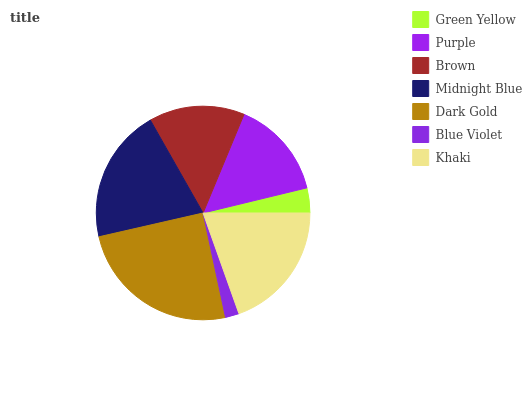Is Blue Violet the minimum?
Answer yes or no. Yes. Is Dark Gold the maximum?
Answer yes or no. Yes. Is Purple the minimum?
Answer yes or no. No. Is Purple the maximum?
Answer yes or no. No. Is Purple greater than Green Yellow?
Answer yes or no. Yes. Is Green Yellow less than Purple?
Answer yes or no. Yes. Is Green Yellow greater than Purple?
Answer yes or no. No. Is Purple less than Green Yellow?
Answer yes or no. No. Is Purple the high median?
Answer yes or no. Yes. Is Purple the low median?
Answer yes or no. Yes. Is Midnight Blue the high median?
Answer yes or no. No. Is Midnight Blue the low median?
Answer yes or no. No. 